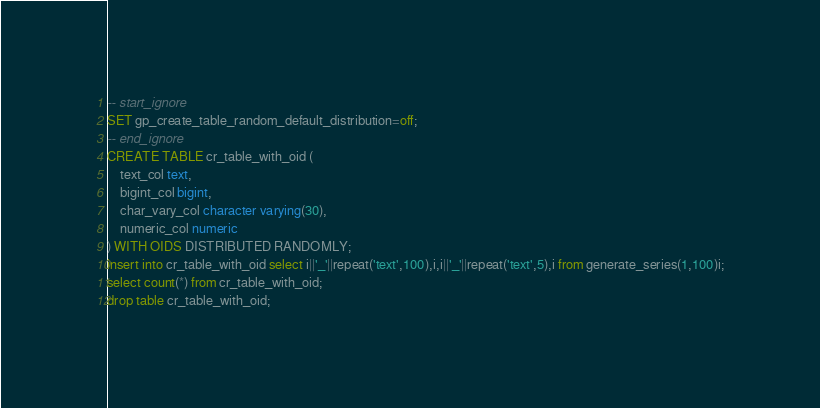<code> <loc_0><loc_0><loc_500><loc_500><_SQL_>-- start_ignore
SET gp_create_table_random_default_distribution=off;
-- end_ignore
CREATE TABLE cr_table_with_oid (
    text_col text,
    bigint_col bigint,
    char_vary_col character varying(30),
    numeric_col numeric
) WITH OIDS DISTRIBUTED RANDOMLY;
insert into cr_table_with_oid select i||'_'||repeat('text',100),i,i||'_'||repeat('text',5),i from generate_series(1,100)i;
select count(*) from cr_table_with_oid;
drop table cr_table_with_oid;
</code> 